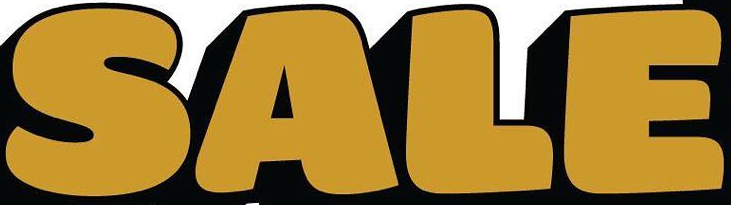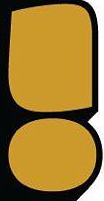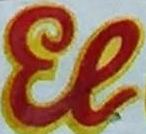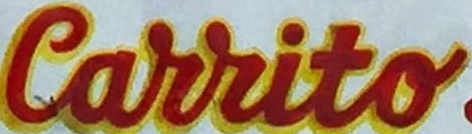Read the text content from these images in order, separated by a semicolon. SALE; !; El; Carrito 